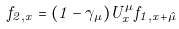<formula> <loc_0><loc_0><loc_500><loc_500>f _ { 2 , { x } } = ( 1 - \gamma _ { \mu } ) U ^ { \mu } _ { x } f _ { 1 , { x } + \hat { \mu } }</formula> 